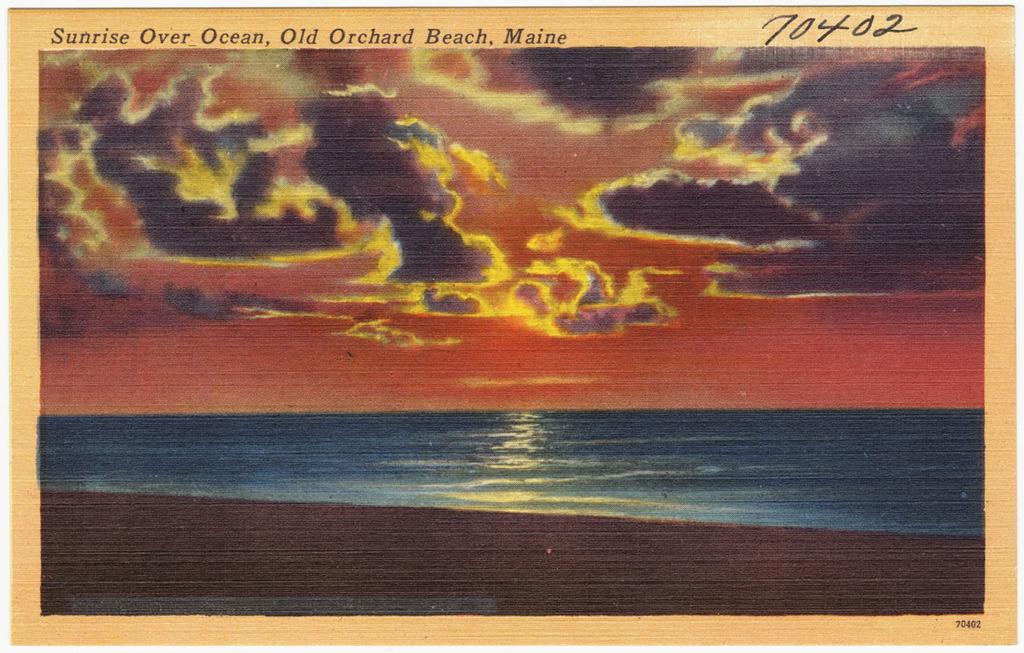What is the scribbled number on the painting?
Give a very brief answer. 70402. What does the blue represent?
Give a very brief answer. Answering does not require reading text in the image. 